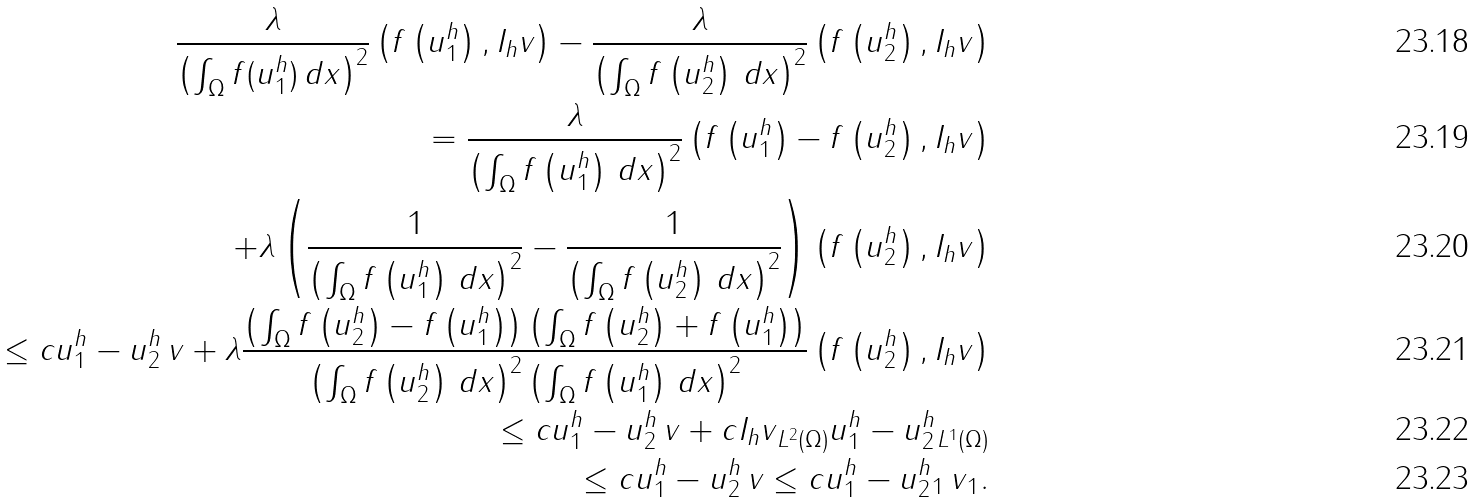Convert formula to latex. <formula><loc_0><loc_0><loc_500><loc_500>\frac { \lambda } { \left ( \int _ { \Omega } f ( u ^ { h } _ { 1 } ) \, d x \right ) ^ { 2 } } \left ( f \left ( u ^ { h } _ { 1 } \right ) , I _ { h } v \right ) - \frac { \lambda } { \left ( \int _ { \Omega } f \left ( u ^ { h } _ { 2 } \right ) \, d x \right ) ^ { 2 } } \left ( f \left ( u ^ { h } _ { 2 } \right ) , I _ { h } v \right ) \\ = \frac { \lambda } { \left ( \int _ { \Omega } f \left ( u ^ { h } _ { 1 } \right ) \, d x \right ) ^ { 2 } } \left ( f \left ( u ^ { h } _ { 1 } \right ) - f \left ( u ^ { h } _ { 2 } \right ) , I _ { h } v \right ) \\ + \lambda \left ( \frac { 1 } { \left ( \int _ { \Omega } f \left ( u ^ { h } _ { 1 } \right ) \, d x \right ) ^ { 2 } } - \frac { 1 } { \left ( \int _ { \Omega } f \left ( u ^ { h } _ { 2 } \right ) \, d x \right ) ^ { 2 } } \right ) \left ( f \left ( u ^ { h } _ { 2 } \right ) , I _ { h } v \right ) \\ \leq c \| u _ { 1 } ^ { h } - u _ { 2 } ^ { h } \| \, \| v \| + \lambda \frac { \left ( \int _ { \Omega } f \left ( u ^ { h } _ { 2 } \right ) - f \left ( u ^ { h } _ { 1 } \right ) \right ) \left ( \int _ { \Omega } f \left ( u ^ { h } _ { 2 } \right ) + f \left ( u ^ { h } _ { 1 } \right ) \right ) } { \left ( \int _ { \Omega } f \left ( u ^ { h } _ { 2 } \right ) \, d x \right ) ^ { 2 } \left ( \int _ { \Omega } f \left ( u ^ { h } _ { 1 } \right ) \, d x \right ) ^ { 2 } } \left ( f \left ( u ^ { h } _ { 2 } \right ) , I _ { h } v \right ) \\ \leq c \| u _ { 1 } ^ { h } - u _ { 2 } ^ { h } \| \, \| v \| + c \| I _ { h } v \| _ { L ^ { 2 } ( \Omega ) } \| u _ { 1 } ^ { h } - u _ { 2 } ^ { h } \| _ { L ^ { 1 } ( \Omega ) } \\ \leq c \| u _ { 1 } ^ { h } - u _ { 2 } ^ { h } \| \, \| v \| \leq c \| u _ { 1 } ^ { h } - u _ { 2 } ^ { h } \| _ { 1 } \, \| v \| _ { 1 } .</formula> 